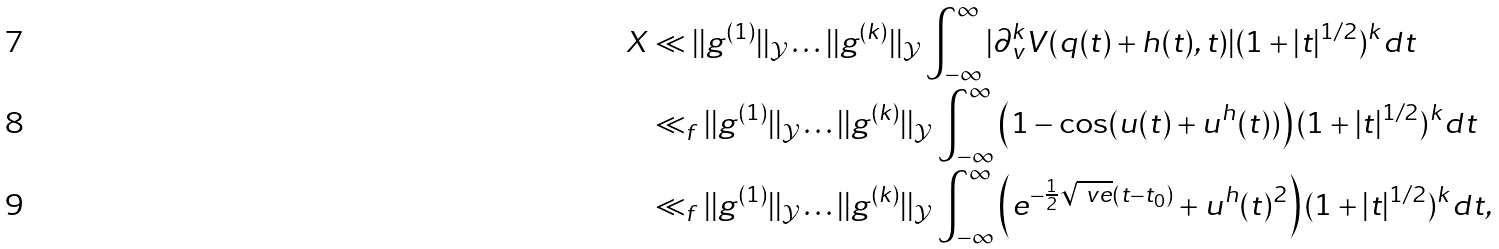Convert formula to latex. <formula><loc_0><loc_0><loc_500><loc_500>X & \ll | | g ^ { ( 1 ) } | | _ { \mathcal { Y } } \dots | | g ^ { ( k ) } | | _ { \mathcal { Y } } \int _ { - \infty } ^ { \infty } | \partial ^ { k } _ { v } V ( q ( t ) + h ( t ) , t ) | ( 1 + | t | ^ { 1 / 2 } ) ^ { k } d t \\ & \ll _ { f } | | g ^ { ( 1 ) } | | _ { \mathcal { Y } } \dots | | g ^ { ( k ) } | | _ { \mathcal { Y } } \int _ { - \infty } ^ { \infty } \left ( 1 - \cos ( u ( t ) + u ^ { h } ( t ) ) \right ) ( 1 + | t | ^ { 1 / 2 } ) ^ { k } d t \\ & \ll _ { f } | | g ^ { ( 1 ) } | | _ { \mathcal { Y } } \dots | | g ^ { ( k ) } | | _ { \mathcal { Y } } \int _ { - \infty } ^ { \infty } \left ( e ^ { - \frac { 1 } { 2 } \sqrt { \ v e } ( t - t _ { 0 } ) } + u ^ { h } ( t ) ^ { 2 } \right ) ( 1 + | t | ^ { 1 / 2 } ) ^ { k } d t ,</formula> 